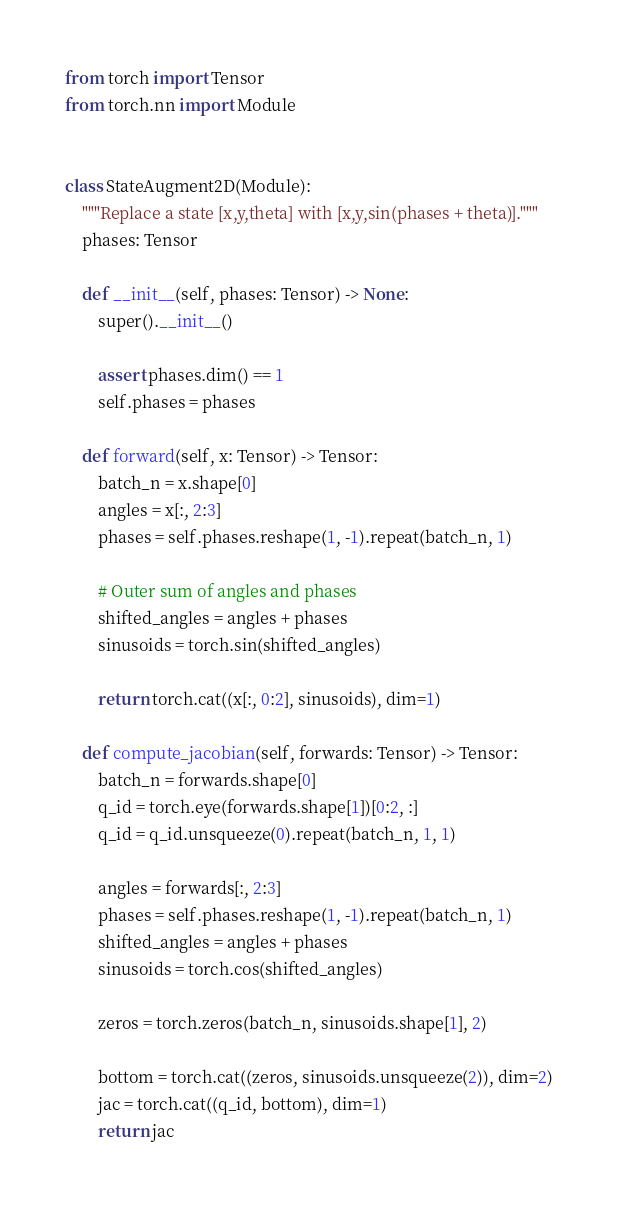<code> <loc_0><loc_0><loc_500><loc_500><_Python_>from torch import Tensor
from torch.nn import Module


class StateAugment2D(Module):
    """Replace a state [x,y,theta] with [x,y,sin(phases + theta)]."""
    phases: Tensor

    def __init__(self, phases: Tensor) -> None:
        super().__init__()

        assert phases.dim() == 1
        self.phases = phases

    def forward(self, x: Tensor) -> Tensor:
        batch_n = x.shape[0]
        angles = x[:, 2:3]
        phases = self.phases.reshape(1, -1).repeat(batch_n, 1)

        # Outer sum of angles and phases
        shifted_angles = angles + phases
        sinusoids = torch.sin(shifted_angles)

        return torch.cat((x[:, 0:2], sinusoids), dim=1)

    def compute_jacobian(self, forwards: Tensor) -> Tensor:
        batch_n = forwards.shape[0]
        q_id = torch.eye(forwards.shape[1])[0:2, :]
        q_id = q_id.unsqueeze(0).repeat(batch_n, 1, 1)

        angles = forwards[:, 2:3]
        phases = self.phases.reshape(1, -1).repeat(batch_n, 1)
        shifted_angles = angles + phases
        sinusoids = torch.cos(shifted_angles)

        zeros = torch.zeros(batch_n, sinusoids.shape[1], 2)

        bottom = torch.cat((zeros, sinusoids.unsqueeze(2)), dim=2)
        jac = torch.cat((q_id, bottom), dim=1)
        return jac
</code> 